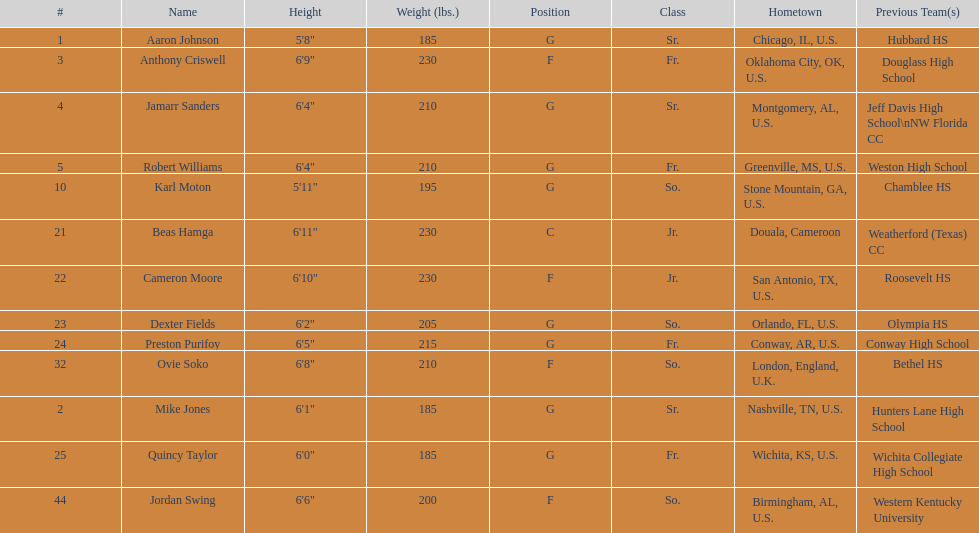What is the count of juniors present in the team? 2. 